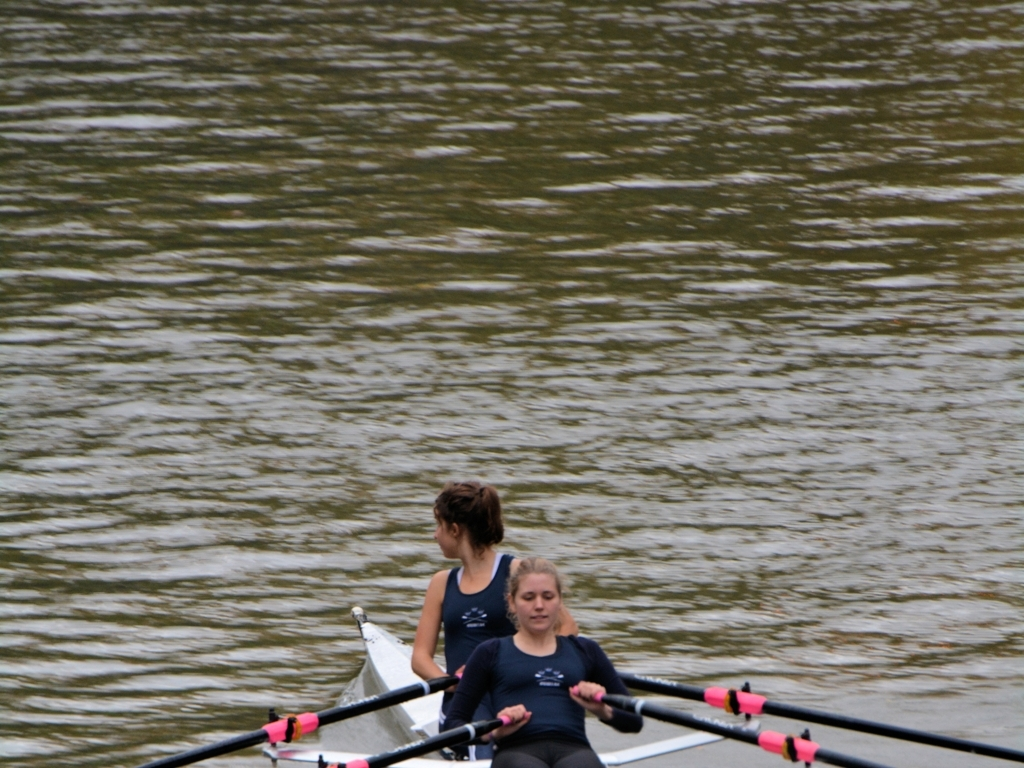Analyze the characteristics of the image and determine its quality based on your findings.
 This image has acceptable lighting, vivid colors. The focus is on the person in the boat, and both the person and the oar have clear features. The water surface in the background is slightly blurred, with a slightly fuzzy ripple effect. Overall, the image quality is good. 